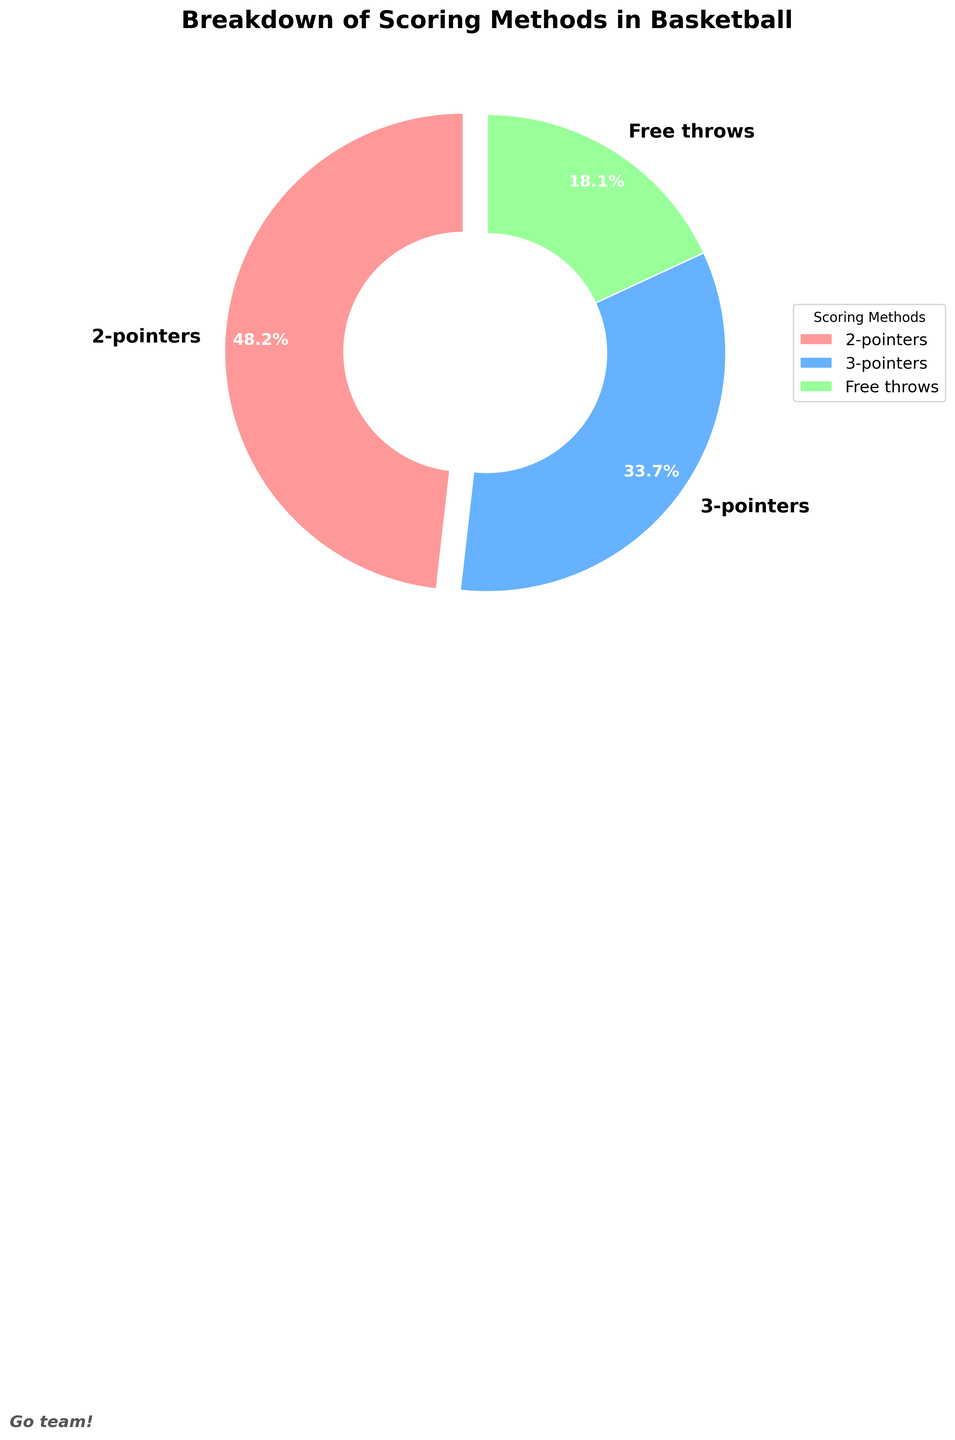What is the percentage of 2-pointers scored? The figure shows different scoring methods and their corresponding percentages. Look for the "2-pointers" slice and read the percentage from there.
Answer: 48.2% How much more common are 2-pointers compared to free throws? Locate the percentages of both 2-pointers and free throws. Subtract the percentage of free throws from the percentage of 2-pointers to find the difference. 48.2% - 18.1% = 30.1%
Answer: 30.1% Which scoring method is the least common? Examine the percentages for all scoring methods. Identify the method with the lowest percentage.
Answer: Free throws By how much do 3-pointers make up the total scoring percentage compared to 2-pointers and free throws combined? Add the percentages of 2-pointers and free throws, then subtract the sum from the percentage of 3-pointers. (48.2% + 18.1%) = 66.3%, then 33.7% - 66.3% = -32.6%
Answer: -32.6% Which scoring methods make up more than half of the total scoring percentage when combined? Add the percentages of different scoring methods to see if their combined value exceeds 50%. Check if 2-pointers + 3-pointers or 3-pointers + free throws exceed the threshold. 48.2% + 33.7% = 81.9% which is greater than 50%.
Answer: 2-pointers and 3-pointers How is the distribution of the scoring methods visually represented in terms of color? The pie chart uses specific colors for each segment. Note the colors used for each scoring method.
Answer: 2-pointers are red, 3-pointers are blue, free throws are green Between 2-pointers and 3-pointers, which scoring method contributes more to the total percentage, and by how much? Compare the percentages of 2-pointers and 3-pointers and subtract the smaller percentage from the larger one. 48.2% is greater than 33.7%, and 48.2% - 33.7% = 14.5%
Answer: 2-pointers by 14.5% If the percentage of 3-pointers increased by 10%, what would be its new percentage? Add 10% to the current percentage of 3-pointers. 33.7% + 10% = 43.7%
Answer: 43.7% What percentage of the total scoring do 2-pointers and free throws make up when combined? Sum the percentages of 2-pointers and free throws to find the combined percentage. 48.2% + 18.1% = 66.3%
Answer: 66.3% 